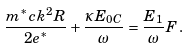Convert formula to latex. <formula><loc_0><loc_0><loc_500><loc_500>\frac { m ^ { \ast } c k ^ { 2 } R } { 2 e ^ { \ast } } + \frac { \kappa E _ { 0 C } } { \omega } = \frac { E _ { 1 } } { \omega } F \, .</formula> 